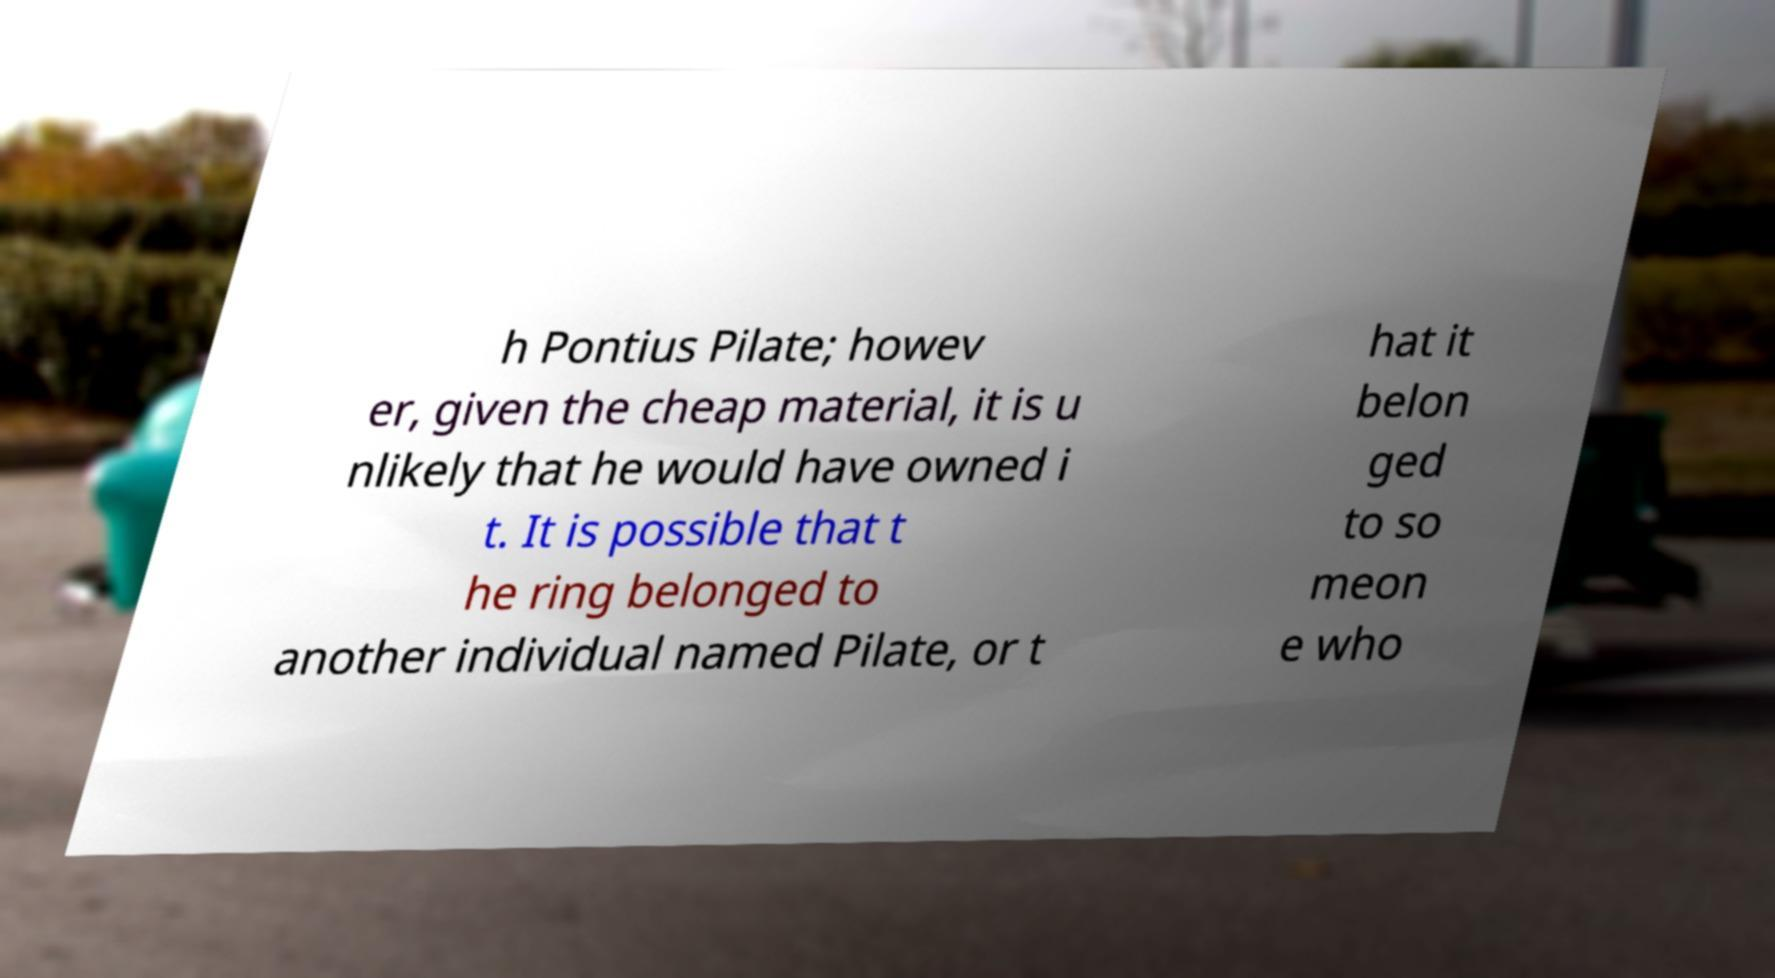There's text embedded in this image that I need extracted. Can you transcribe it verbatim? h Pontius Pilate; howev er, given the cheap material, it is u nlikely that he would have owned i t. It is possible that t he ring belonged to another individual named Pilate, or t hat it belon ged to so meon e who 